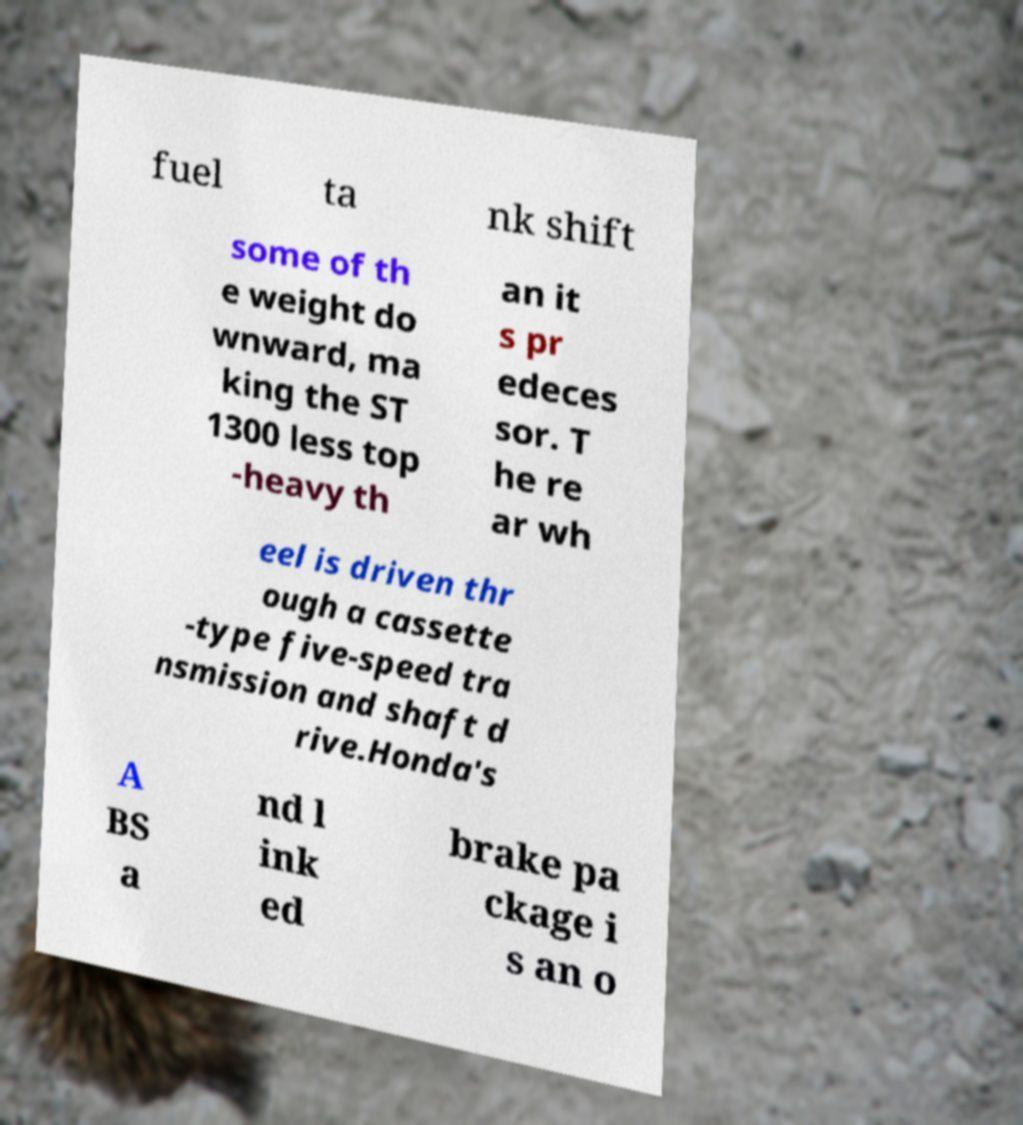What messages or text are displayed in this image? I need them in a readable, typed format. fuel ta nk shift some of th e weight do wnward, ma king the ST 1300 less top -heavy th an it s pr edeces sor. T he re ar wh eel is driven thr ough a cassette -type five-speed tra nsmission and shaft d rive.Honda's A BS a nd l ink ed brake pa ckage i s an o 